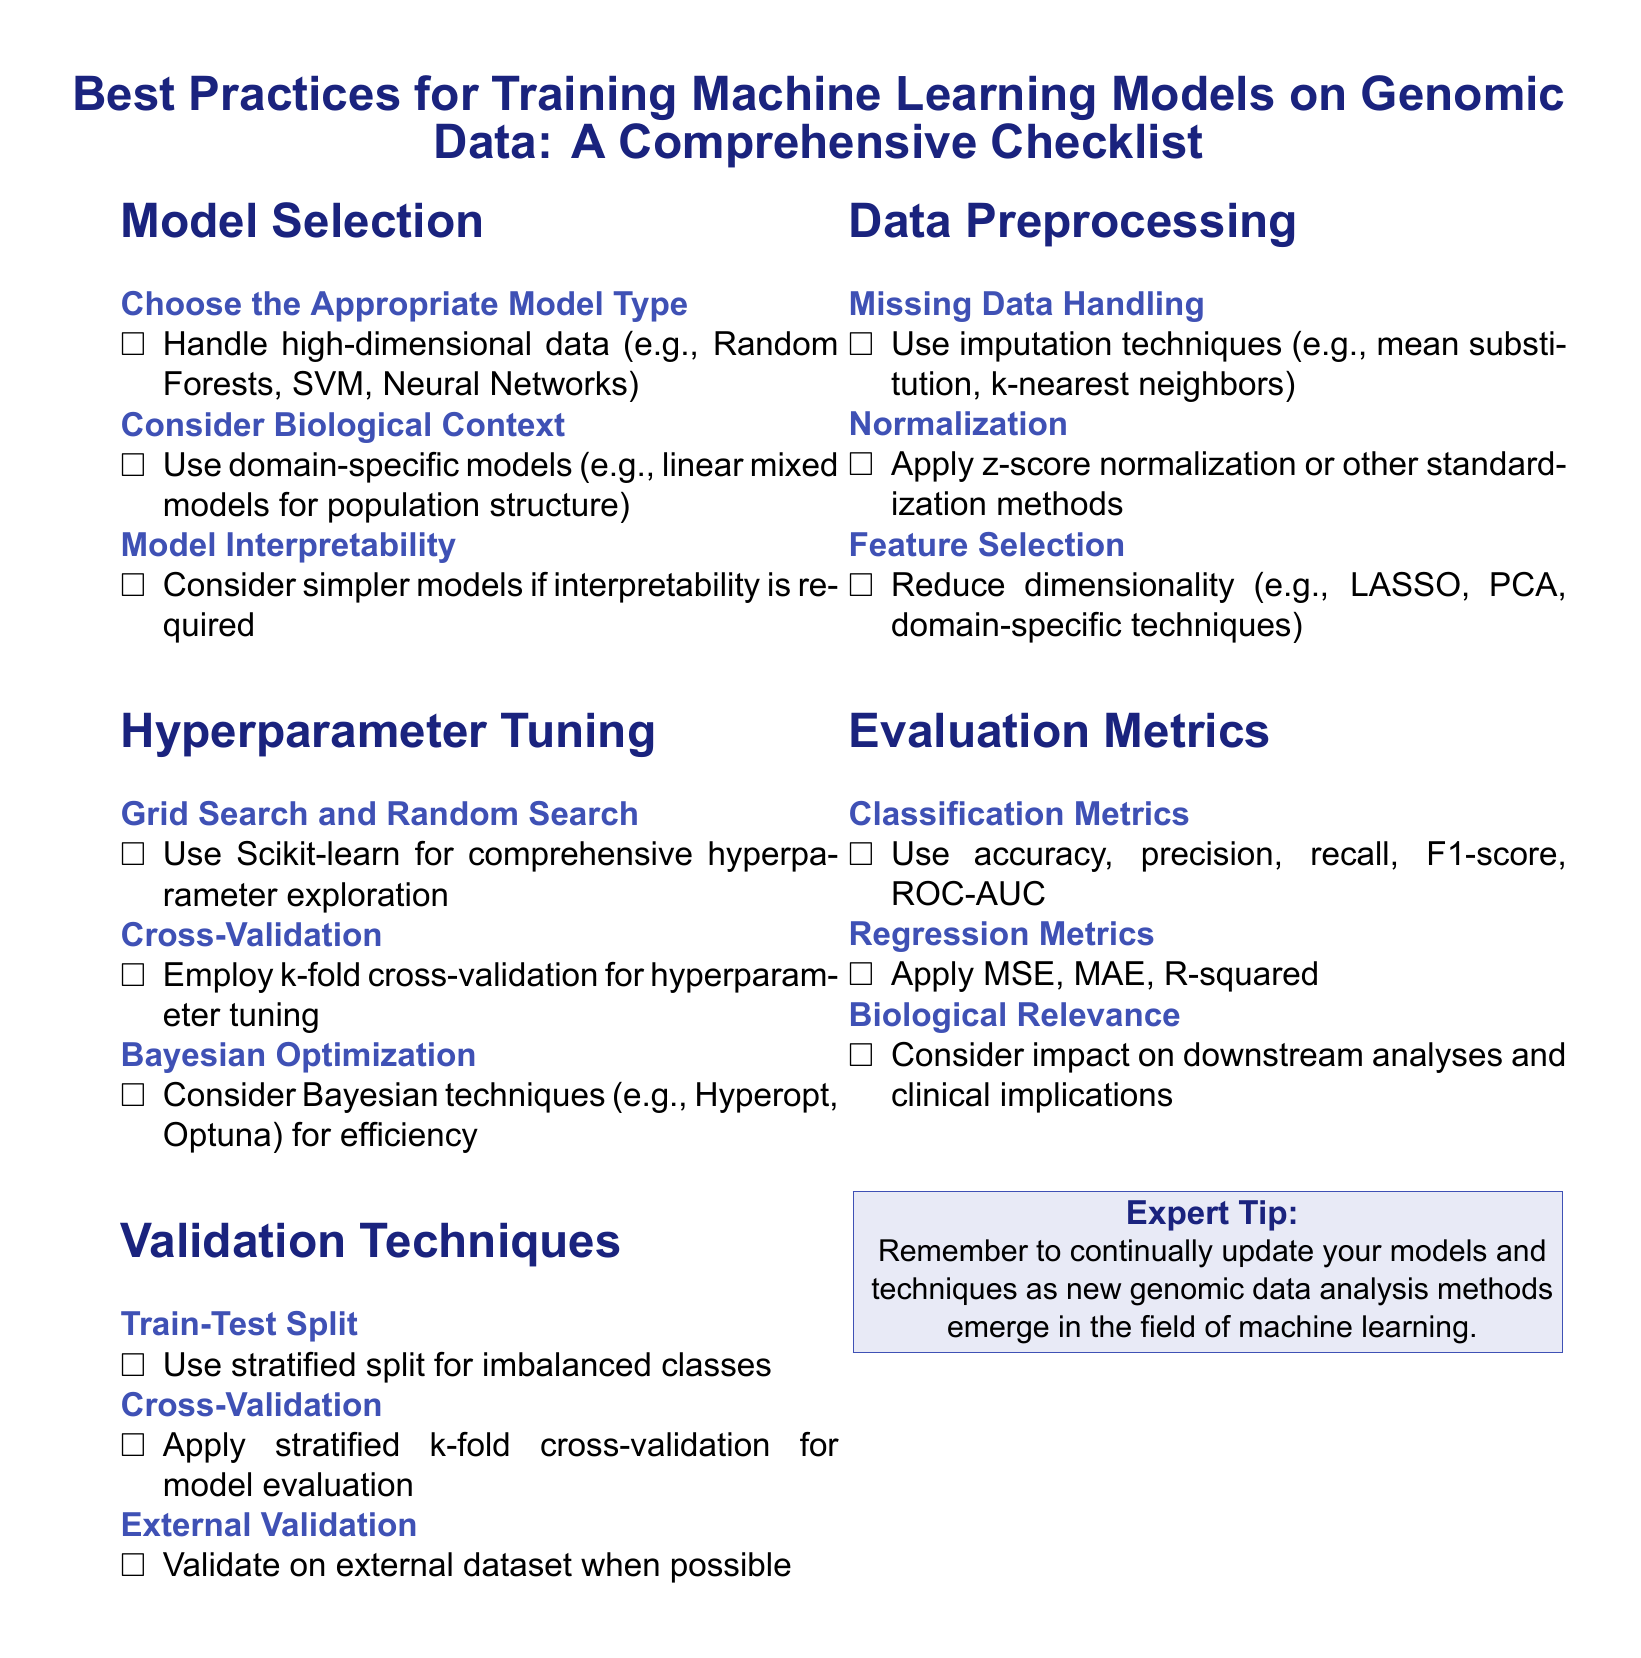What are the three model types mentioned for handling high-dimensional data? The document lists Random Forests, SVM, and Neural Networks as model types for handling high-dimensional data.
Answer: Random Forests, SVM, Neural Networks What is one technique recommended for hyperparameter tuning? The document suggests using Scikit-learn for comprehensive hyperparameter exploration.
Answer: Scikit-learn Which method is advised for imputation of missing data? The document mentions mean substitution and k-nearest neighbors as imputation techniques for handling missing data.
Answer: mean substitution, k-nearest neighbors What evaluation metric is applicable to classification tasks? The document recommends accuracy, precision, recall, F1-score, and ROC-AUC for classification evaluation.
Answer: accuracy, precision, recall, F1-score, ROC-AUC What type of cross-validation should be employed for model evaluation? The document specifies applying stratified k-fold cross-validation for model evaluation.
Answer: stratified k-fold cross-validation Which validation approach is suggested for external datasets? The document indicates validating on an external dataset when possible as a preferred approach.
Answer: external dataset What technique is recommended for normalization in preprocessing? The document advises applying z-score normalization or other standardization methods for normalization.
Answer: z-score normalization What is emphasized as important for biological relevance in evaluation metrics? The document highlights considering the impact on downstream analyses and clinical implications for biological relevance.
Answer: impact on downstream analyses and clinical implications 